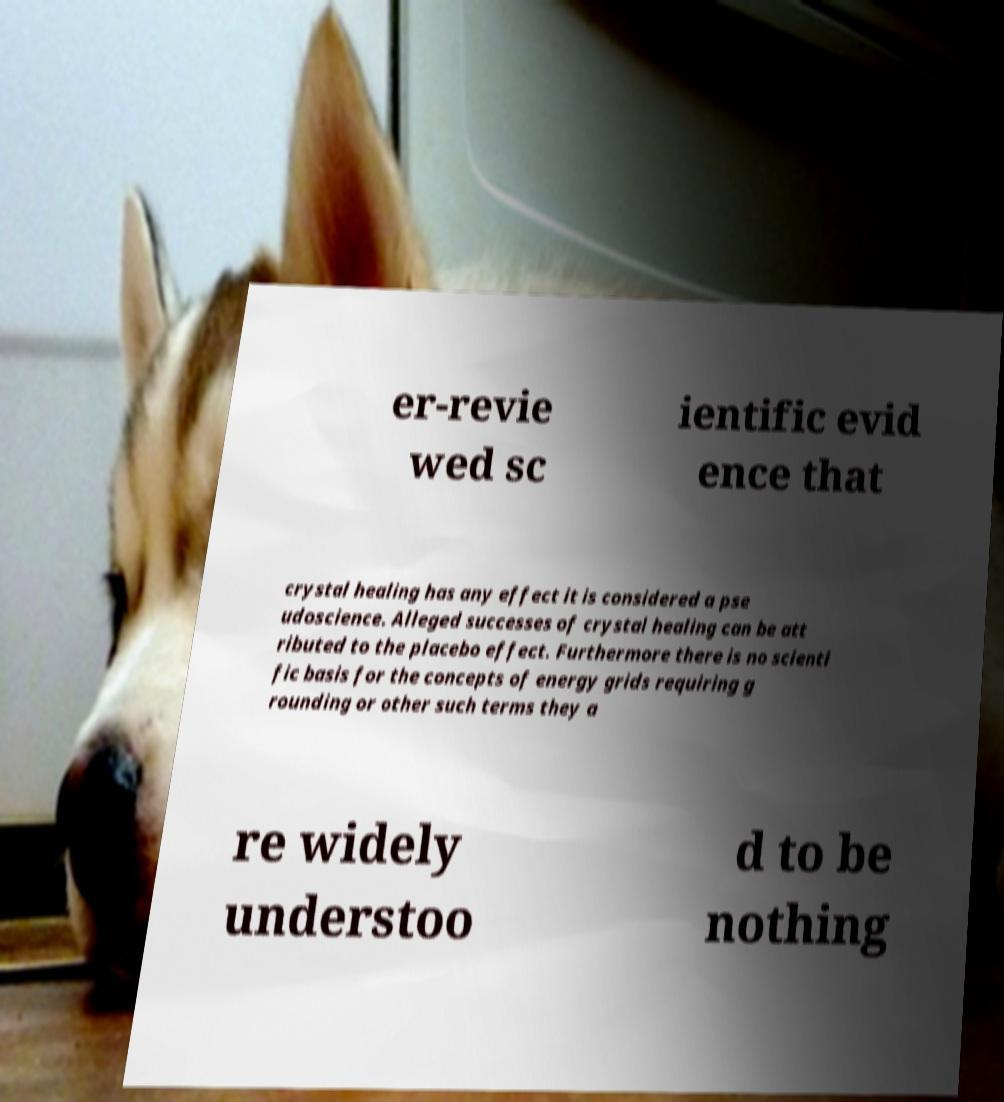Can you accurately transcribe the text from the provided image for me? er-revie wed sc ientific evid ence that crystal healing has any effect it is considered a pse udoscience. Alleged successes of crystal healing can be att ributed to the placebo effect. Furthermore there is no scienti fic basis for the concepts of energy grids requiring g rounding or other such terms they a re widely understoo d to be nothing 